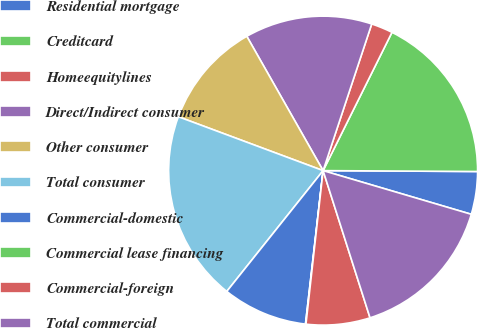Convert chart to OTSL. <chart><loc_0><loc_0><loc_500><loc_500><pie_chart><fcel>Residential mortgage<fcel>Creditcard<fcel>Homeequitylines<fcel>Direct/Indirect consumer<fcel>Other consumer<fcel>Total consumer<fcel>Commercial-domestic<fcel>Commercial lease financing<fcel>Commercial-foreign<fcel>Total commercial<nl><fcel>4.47%<fcel>17.73%<fcel>2.26%<fcel>13.31%<fcel>11.1%<fcel>19.95%<fcel>8.89%<fcel>0.05%<fcel>6.68%<fcel>15.52%<nl></chart> 